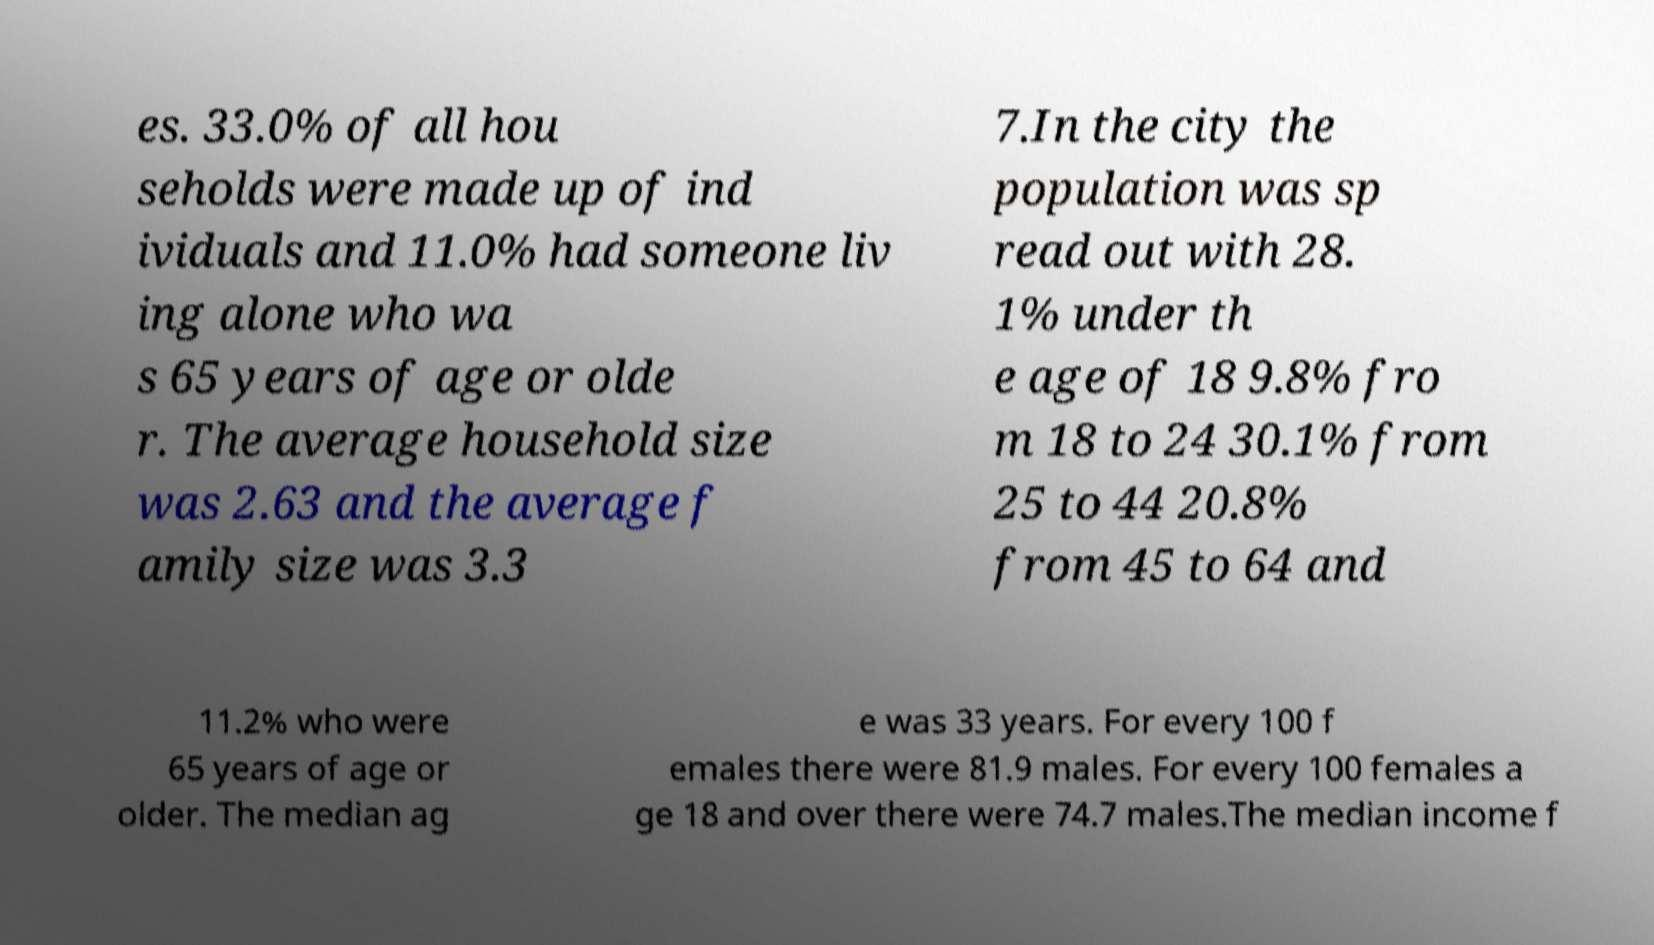Could you assist in decoding the text presented in this image and type it out clearly? es. 33.0% of all hou seholds were made up of ind ividuals and 11.0% had someone liv ing alone who wa s 65 years of age or olde r. The average household size was 2.63 and the average f amily size was 3.3 7.In the city the population was sp read out with 28. 1% under th e age of 18 9.8% fro m 18 to 24 30.1% from 25 to 44 20.8% from 45 to 64 and 11.2% who were 65 years of age or older. The median ag e was 33 years. For every 100 f emales there were 81.9 males. For every 100 females a ge 18 and over there were 74.7 males.The median income f 